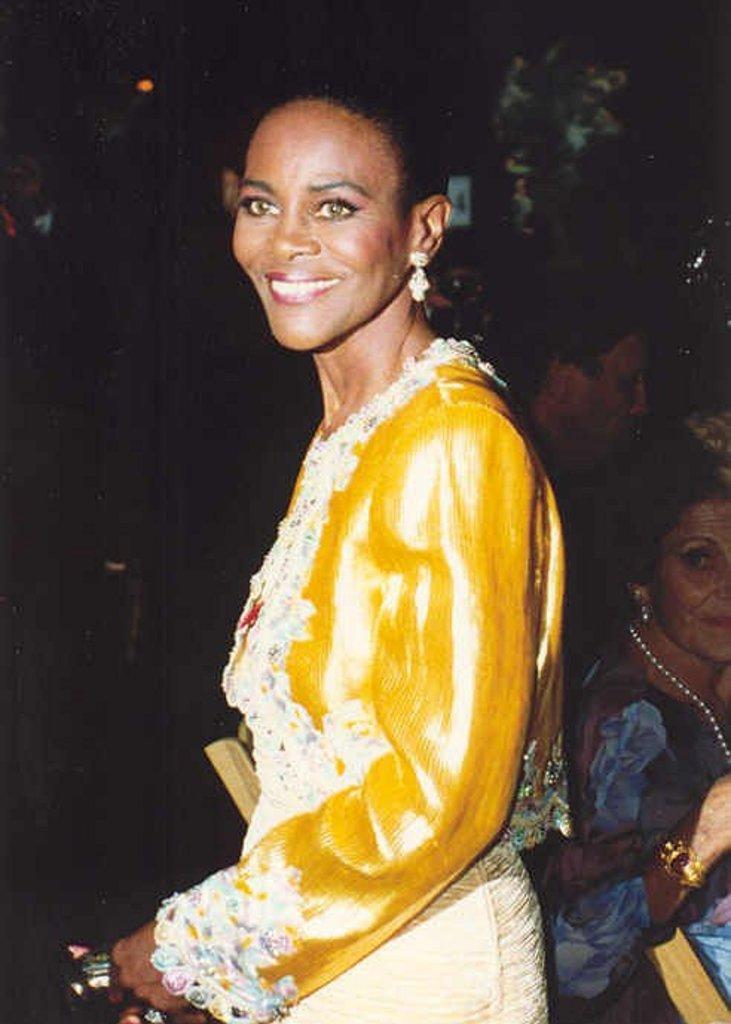Describe this image in one or two sentences. Here in this picture we can see a woman standing and she is wearing a yellow colored top of the, smiling and behind her we can see some people sitting on chairs over there. 